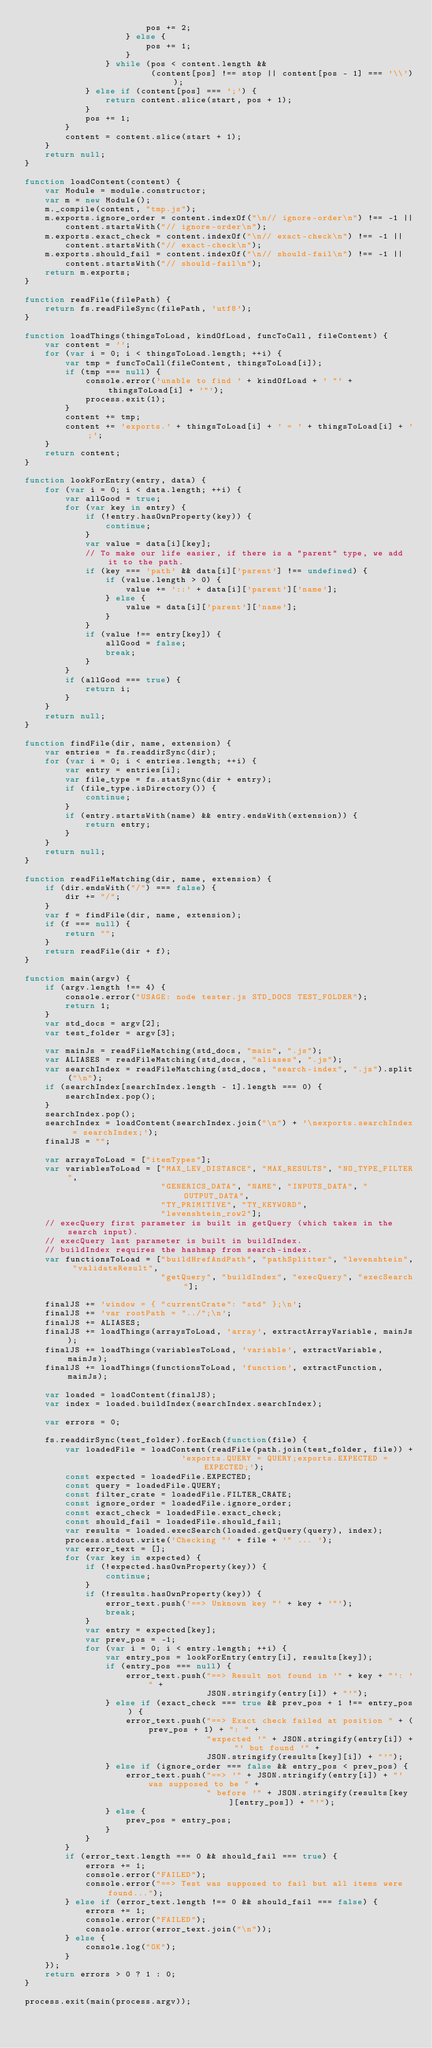<code> <loc_0><loc_0><loc_500><loc_500><_JavaScript_>                        pos += 2;
                    } else {
                        pos += 1;
                    }
                } while (pos < content.length &&
                         (content[pos] !== stop || content[pos - 1] === '\\'));
            } else if (content[pos] === ';') {
                return content.slice(start, pos + 1);
            }
            pos += 1;
        }
        content = content.slice(start + 1);
    }
    return null;
}

function loadContent(content) {
    var Module = module.constructor;
    var m = new Module();
    m._compile(content, "tmp.js");
    m.exports.ignore_order = content.indexOf("\n// ignore-order\n") !== -1 ||
        content.startsWith("// ignore-order\n");
    m.exports.exact_check = content.indexOf("\n// exact-check\n") !== -1 ||
        content.startsWith("// exact-check\n");
    m.exports.should_fail = content.indexOf("\n// should-fail\n") !== -1 ||
        content.startsWith("// should-fail\n");
    return m.exports;
}

function readFile(filePath) {
    return fs.readFileSync(filePath, 'utf8');
}

function loadThings(thingsToLoad, kindOfLoad, funcToCall, fileContent) {
    var content = '';
    for (var i = 0; i < thingsToLoad.length; ++i) {
        var tmp = funcToCall(fileContent, thingsToLoad[i]);
        if (tmp === null) {
            console.error('unable to find ' + kindOfLoad + ' "' + thingsToLoad[i] + '"');
            process.exit(1);
        }
        content += tmp;
        content += 'exports.' + thingsToLoad[i] + ' = ' + thingsToLoad[i] + ';';
    }
    return content;
}

function lookForEntry(entry, data) {
    for (var i = 0; i < data.length; ++i) {
        var allGood = true;
        for (var key in entry) {
            if (!entry.hasOwnProperty(key)) {
                continue;
            }
            var value = data[i][key];
            // To make our life easier, if there is a "parent" type, we add it to the path.
            if (key === 'path' && data[i]['parent'] !== undefined) {
                if (value.length > 0) {
                    value += '::' + data[i]['parent']['name'];
                } else {
                    value = data[i]['parent']['name'];
                }
            }
            if (value !== entry[key]) {
                allGood = false;
                break;
            }
        }
        if (allGood === true) {
            return i;
        }
    }
    return null;
}

function findFile(dir, name, extension) {
    var entries = fs.readdirSync(dir);
    for (var i = 0; i < entries.length; ++i) {
        var entry = entries[i];
        var file_type = fs.statSync(dir + entry);
        if (file_type.isDirectory()) {
            continue;
        }
        if (entry.startsWith(name) && entry.endsWith(extension)) {
            return entry;
        }
    }
    return null;
}

function readFileMatching(dir, name, extension) {
    if (dir.endsWith("/") === false) {
        dir += "/";
    }
    var f = findFile(dir, name, extension);
    if (f === null) {
        return "";
    }
    return readFile(dir + f);
}

function main(argv) {
    if (argv.length !== 4) {
        console.error("USAGE: node tester.js STD_DOCS TEST_FOLDER");
        return 1;
    }
    var std_docs = argv[2];
    var test_folder = argv[3];

    var mainJs = readFileMatching(std_docs, "main", ".js");
    var ALIASES = readFileMatching(std_docs, "aliases", ".js");
    var searchIndex = readFileMatching(std_docs, "search-index", ".js").split("\n");
    if (searchIndex[searchIndex.length - 1].length === 0) {
        searchIndex.pop();
    }
    searchIndex.pop();
    searchIndex = loadContent(searchIndex.join("\n") + '\nexports.searchIndex = searchIndex;');
    finalJS = "";

    var arraysToLoad = ["itemTypes"];
    var variablesToLoad = ["MAX_LEV_DISTANCE", "MAX_RESULTS", "NO_TYPE_FILTER",
                           "GENERICS_DATA", "NAME", "INPUTS_DATA", "OUTPUT_DATA",
                           "TY_PRIMITIVE", "TY_KEYWORD",
                           "levenshtein_row2"];
    // execQuery first parameter is built in getQuery (which takes in the search input).
    // execQuery last parameter is built in buildIndex.
    // buildIndex requires the hashmap from search-index.
    var functionsToLoad = ["buildHrefAndPath", "pathSplitter", "levenshtein", "validateResult",
                           "getQuery", "buildIndex", "execQuery", "execSearch"];

    finalJS += 'window = { "currentCrate": "std" };\n';
    finalJS += 'var rootPath = "../";\n';
    finalJS += ALIASES;
    finalJS += loadThings(arraysToLoad, 'array', extractArrayVariable, mainJs);
    finalJS += loadThings(variablesToLoad, 'variable', extractVariable, mainJs);
    finalJS += loadThings(functionsToLoad, 'function', extractFunction, mainJs);

    var loaded = loadContent(finalJS);
    var index = loaded.buildIndex(searchIndex.searchIndex);

    var errors = 0;

    fs.readdirSync(test_folder).forEach(function(file) {
        var loadedFile = loadContent(readFile(path.join(test_folder, file)) +
                               'exports.QUERY = QUERY;exports.EXPECTED = EXPECTED;');
        const expected = loadedFile.EXPECTED;
        const query = loadedFile.QUERY;
        const filter_crate = loadedFile.FILTER_CRATE;
        const ignore_order = loadedFile.ignore_order;
        const exact_check = loadedFile.exact_check;
        const should_fail = loadedFile.should_fail;
        var results = loaded.execSearch(loaded.getQuery(query), index);
        process.stdout.write('Checking "' + file + '" ... ');
        var error_text = [];
        for (var key in expected) {
            if (!expected.hasOwnProperty(key)) {
                continue;
            }
            if (!results.hasOwnProperty(key)) {
                error_text.push('==> Unknown key "' + key + '"');
                break;
            }
            var entry = expected[key];
            var prev_pos = -1;
            for (var i = 0; i < entry.length; ++i) {
                var entry_pos = lookForEntry(entry[i], results[key]);
                if (entry_pos === null) {
                    error_text.push("==> Result not found in '" + key + "': '" +
                                    JSON.stringify(entry[i]) + "'");
                } else if (exact_check === true && prev_pos + 1 !== entry_pos) {
                    error_text.push("==> Exact check failed at position " + (prev_pos + 1) + ": " +
                                    "expected '" + JSON.stringify(entry[i]) + "' but found '" +
                                    JSON.stringify(results[key][i]) + "'");
                } else if (ignore_order === false && entry_pos < prev_pos) {
                    error_text.push("==> '" + JSON.stringify(entry[i]) + "' was supposed to be " +
                                    " before '" + JSON.stringify(results[key][entry_pos]) + "'");
                } else {
                    prev_pos = entry_pos;
                }
            }
        }
        if (error_text.length === 0 && should_fail === true) {
            errors += 1;
            console.error("FAILED");
            console.error("==> Test was supposed to fail but all items were found...");
        } else if (error_text.length !== 0 && should_fail === false) {
            errors += 1;
            console.error("FAILED");
            console.error(error_text.join("\n"));
        } else {
            console.log("OK");
        }
    });
    return errors > 0 ? 1 : 0;
}

process.exit(main(process.argv));
</code> 